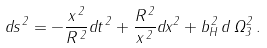Convert formula to latex. <formula><loc_0><loc_0><loc_500><loc_500>d s ^ { \, 2 } = - \frac { x ^ { \, 2 } } { R ^ { \, 2 } } d t ^ { \, 2 } + \frac { R ^ { \, 2 } } { x ^ { \, 2 } } d x ^ { 2 } + b _ { H } ^ { \, 2 } \, d \, \Omega _ { 3 } ^ { 2 } \, .</formula> 